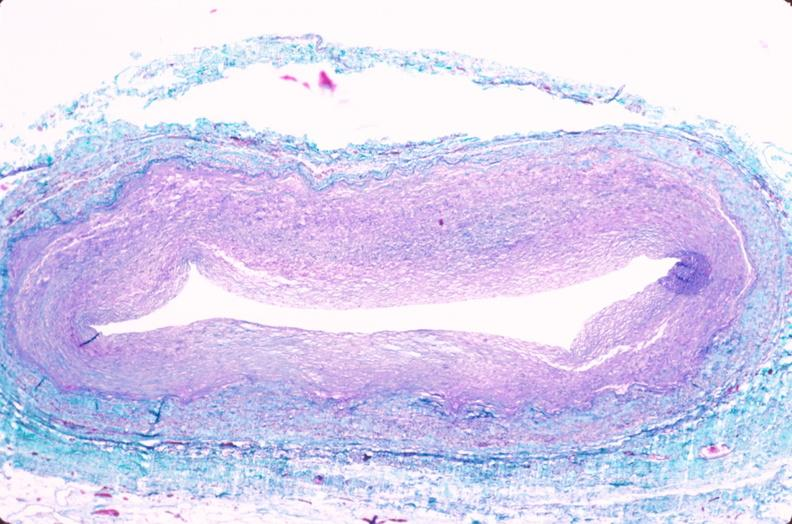what is present?
Answer the question using a single word or phrase. Cardiovascular 